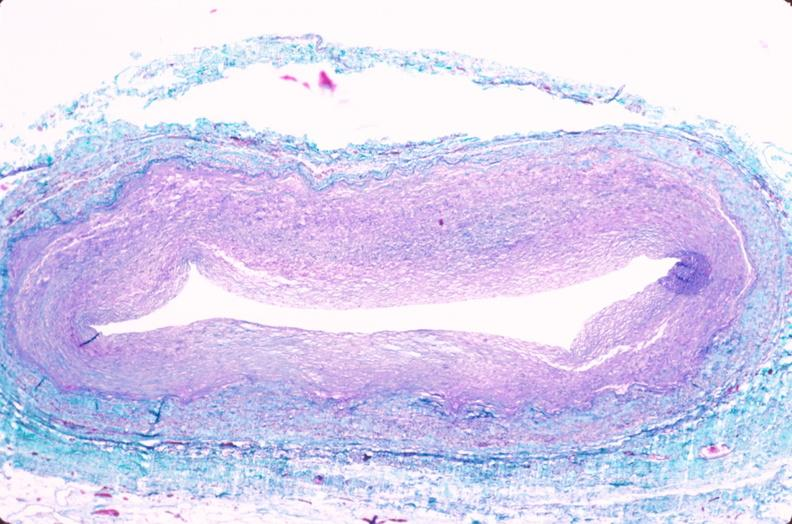what is present?
Answer the question using a single word or phrase. Cardiovascular 